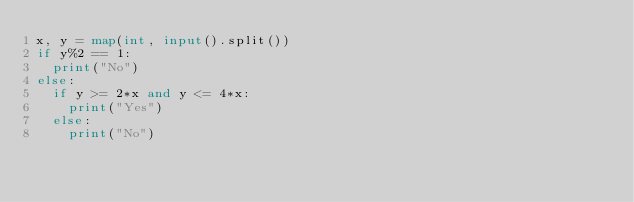<code> <loc_0><loc_0><loc_500><loc_500><_Python_>x, y = map(int, input().split())
if y%2 == 1:
  print("No")
else:
  if y >= 2*x and y <= 4*x:
    print("Yes")
  else:
    print("No")</code> 